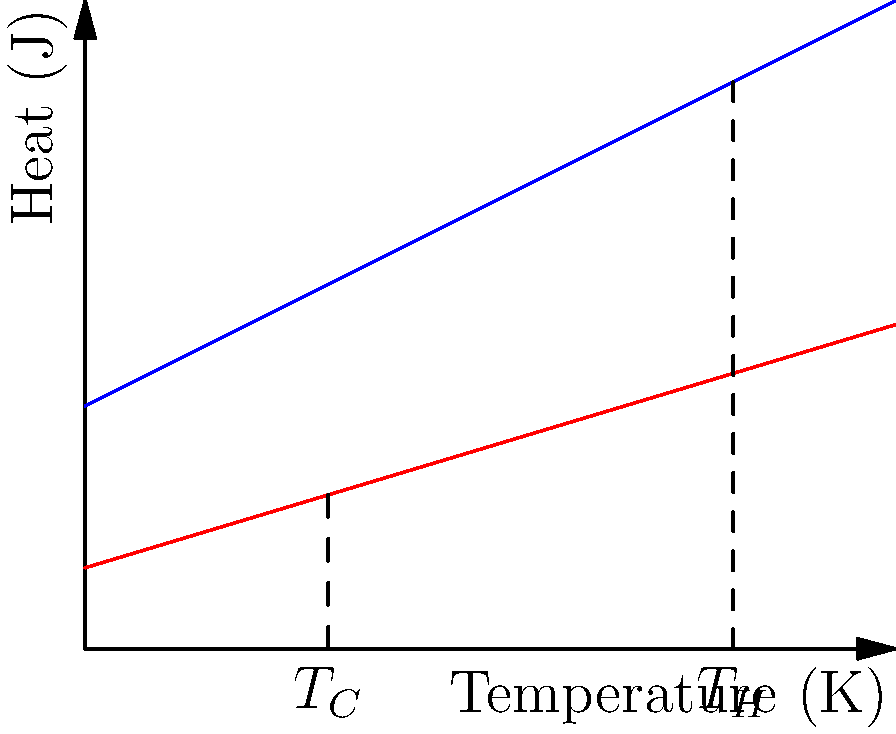At your startup's eco-friendly themed party, you're discussing heat engine efficiency with a colleague. Given a heat engine operating between a hot reservoir at 800 K and a cold reservoir at 300 K, calculate its maximum theoretical efficiency. How might this relate to the energy efficiency of your office's HVAC system? Let's approach this step-by-step:

1) The maximum theoretical efficiency of a heat engine is given by the Carnot efficiency:

   $$\eta_{max} = 1 - \frac{T_C}{T_H}$$

   Where $T_C$ is the temperature of the cold reservoir and $T_H$ is the temperature of the hot reservoir.

2) We're given:
   $T_H = 800$ K
   $T_C = 300$ K

3) Plugging these values into our equation:

   $$\eta_{max} = 1 - \frac{300\text{ K}}{800\text{ K}}$$

4) Simplifying:
   $$\eta_{max} = 1 - 0.375 = 0.625$$

5) Converting to a percentage:
   $$\eta_{max} = 0.625 \times 100\% = 62.5\%$$

This means the maximum theoretical efficiency of this heat engine is 62.5%.

Relating to an office HVAC system: While HVAC systems don't typically reach this theoretical maximum, understanding these principles can help in optimizing energy usage. For instance, minimizing the temperature difference between indoor and outdoor environments can improve efficiency, which could be an interesting point for your eco-friendly party discussion.
Answer: 62.5% 